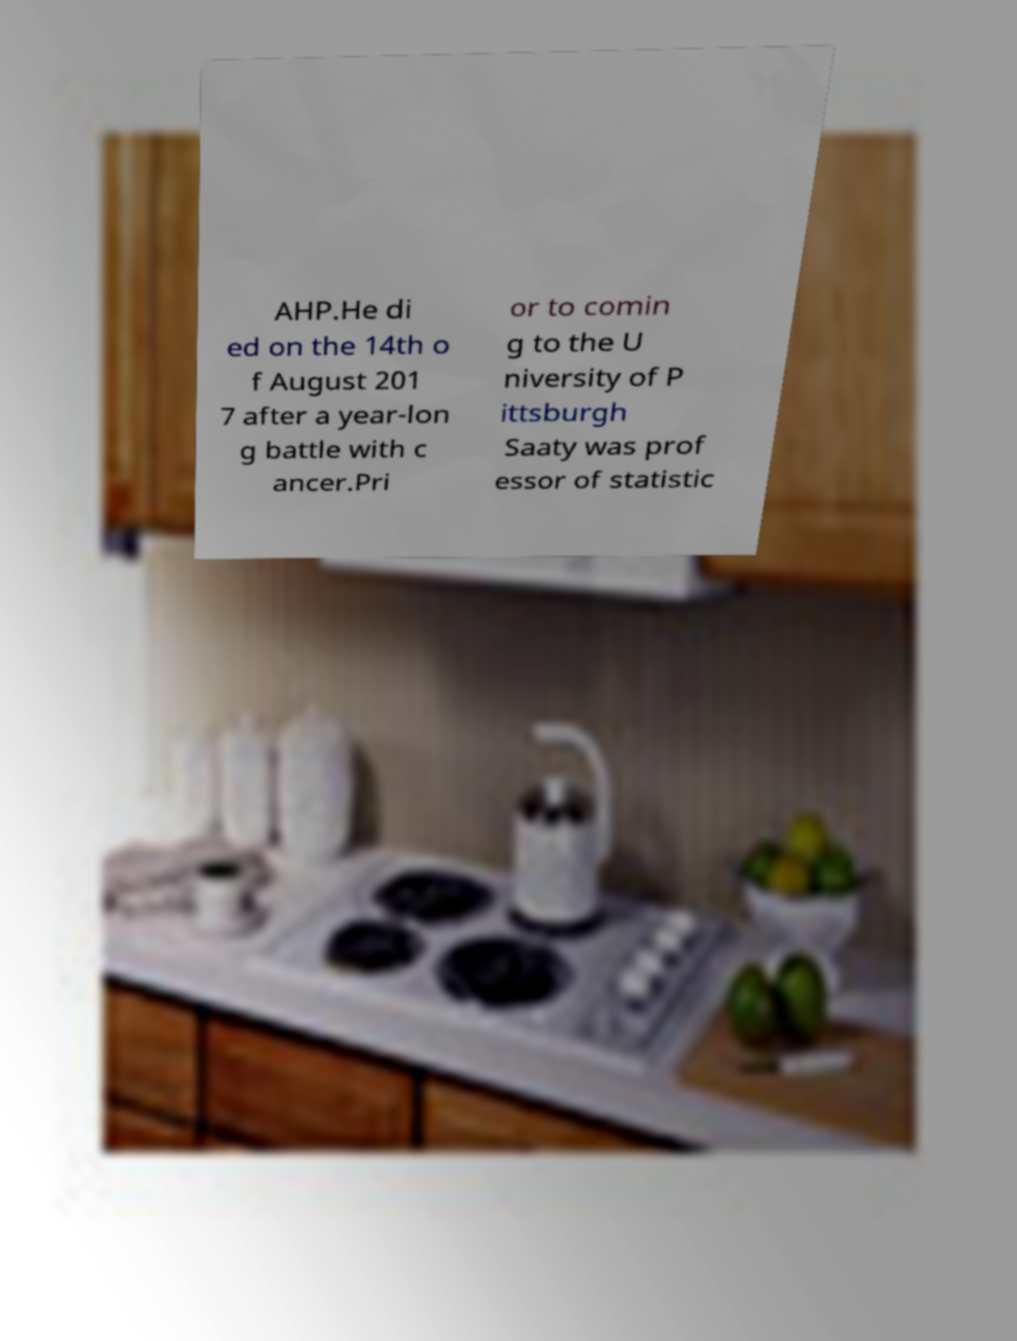Please identify and transcribe the text found in this image. AHP.He di ed on the 14th o f August 201 7 after a year-lon g battle with c ancer.Pri or to comin g to the U niversity of P ittsburgh Saaty was prof essor of statistic 